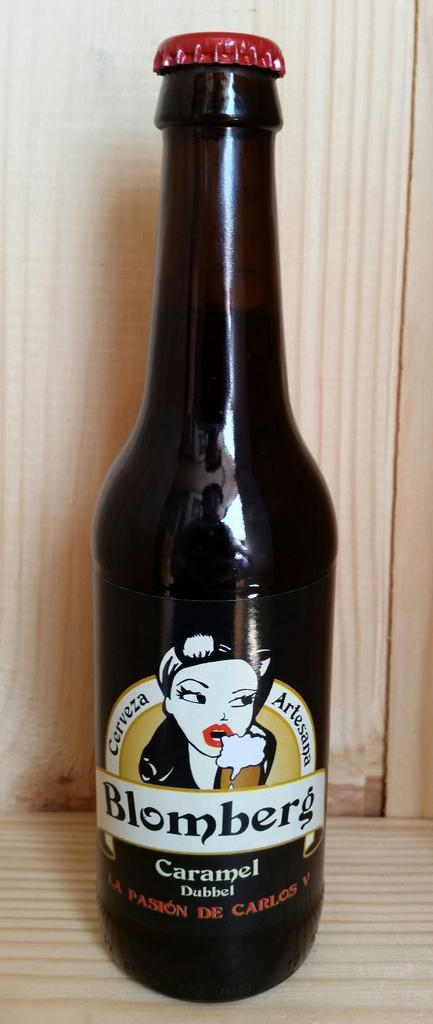<image>
Relay a brief, clear account of the picture shown. A bottle of Blomberg beer features a woman with bright red lipstick on the labe. 